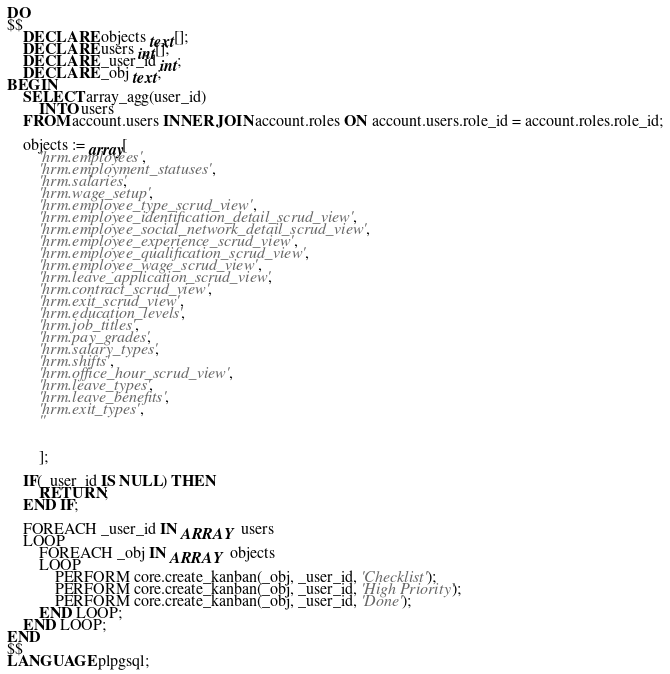<code> <loc_0><loc_0><loc_500><loc_500><_SQL_>DO
$$
    DECLARE objects text[];
    DECLARE users int[];
    DECLARE _user_id int;
    DECLARE _obj text;
BEGIN
    SELECT array_agg(user_id)
        INTO users
    FROM account.users INNER JOIN account.roles ON account.users.role_id = account.roles.role_id;

    objects := array[
        'hrm.employees', 
        'hrm.employment_statuses',
        'hrm.salaries',
        'hrm.wage_setup',
        'hrm.employee_type_scrud_view',
        'hrm.employee_identification_detail_scrud_view',
        'hrm.employee_social_network_detail_scrud_view',
        'hrm.employee_experience_scrud_view',
        'hrm.employee_qualification_scrud_view',
        'hrm.employee_wage_scrud_view',
        'hrm.leave_application_scrud_view',
        'hrm.contract_scrud_view',
        'hrm.exit_scrud_view',
        'hrm.education_levels',
        'hrm.job_titles',
        'hrm.pay_grades',
        'hrm.salary_types',
        'hrm.shifts',
        'hrm.office_hour_scrud_view',
        'hrm.leave_types',
        'hrm.leave_benefits',
        'hrm.exit_types',
        ''
        
        
        ];

    IF(_user_id IS NULL) THEN
        RETURN;
    END IF;

    FOREACH _user_id IN ARRAY users
    LOOP
        FOREACH _obj IN ARRAY objects
        LOOP
            PERFORM core.create_kanban(_obj, _user_id, 'Checklist');
            PERFORM core.create_kanban(_obj, _user_id, 'High Priority');
            PERFORM core.create_kanban(_obj, _user_id, 'Done');
        END LOOP;
    END LOOP;
END
$$
LANGUAGE plpgsql;</code> 